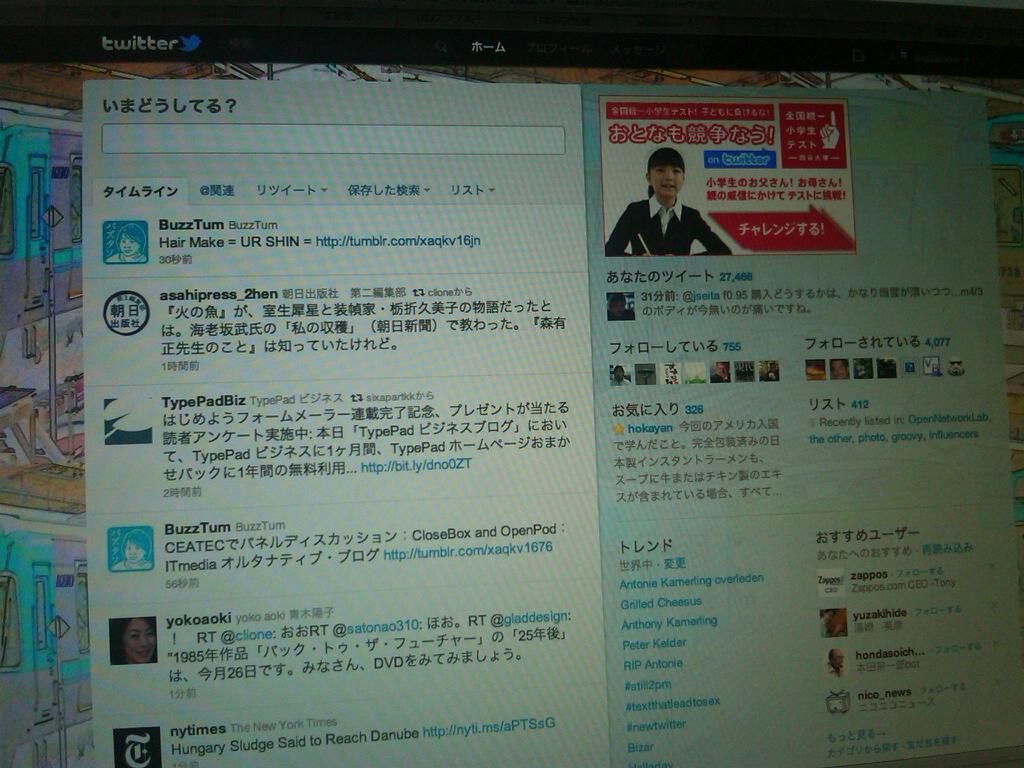<image>
Render a clear and concise summary of the photo. A screenshot of a computer that has a bunch of Asian writing on it. 